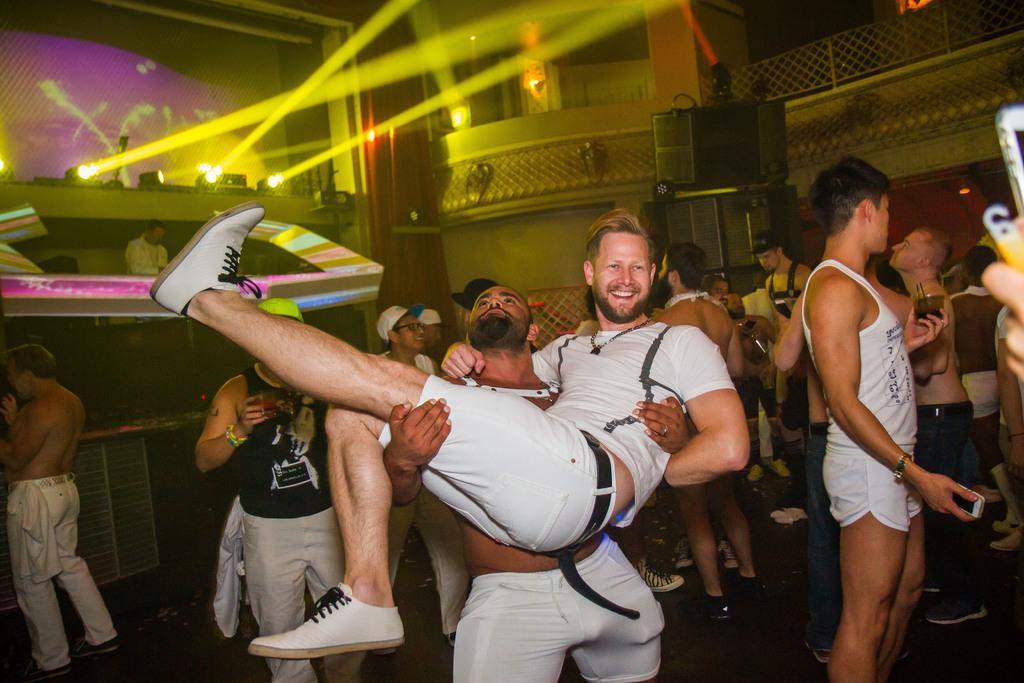In one or two sentences, can you explain what this image depicts? In this image there are few people in a room, there is a person playing music, few lights at the top, a few speakers, some objects attached to the wall and some lighting. 